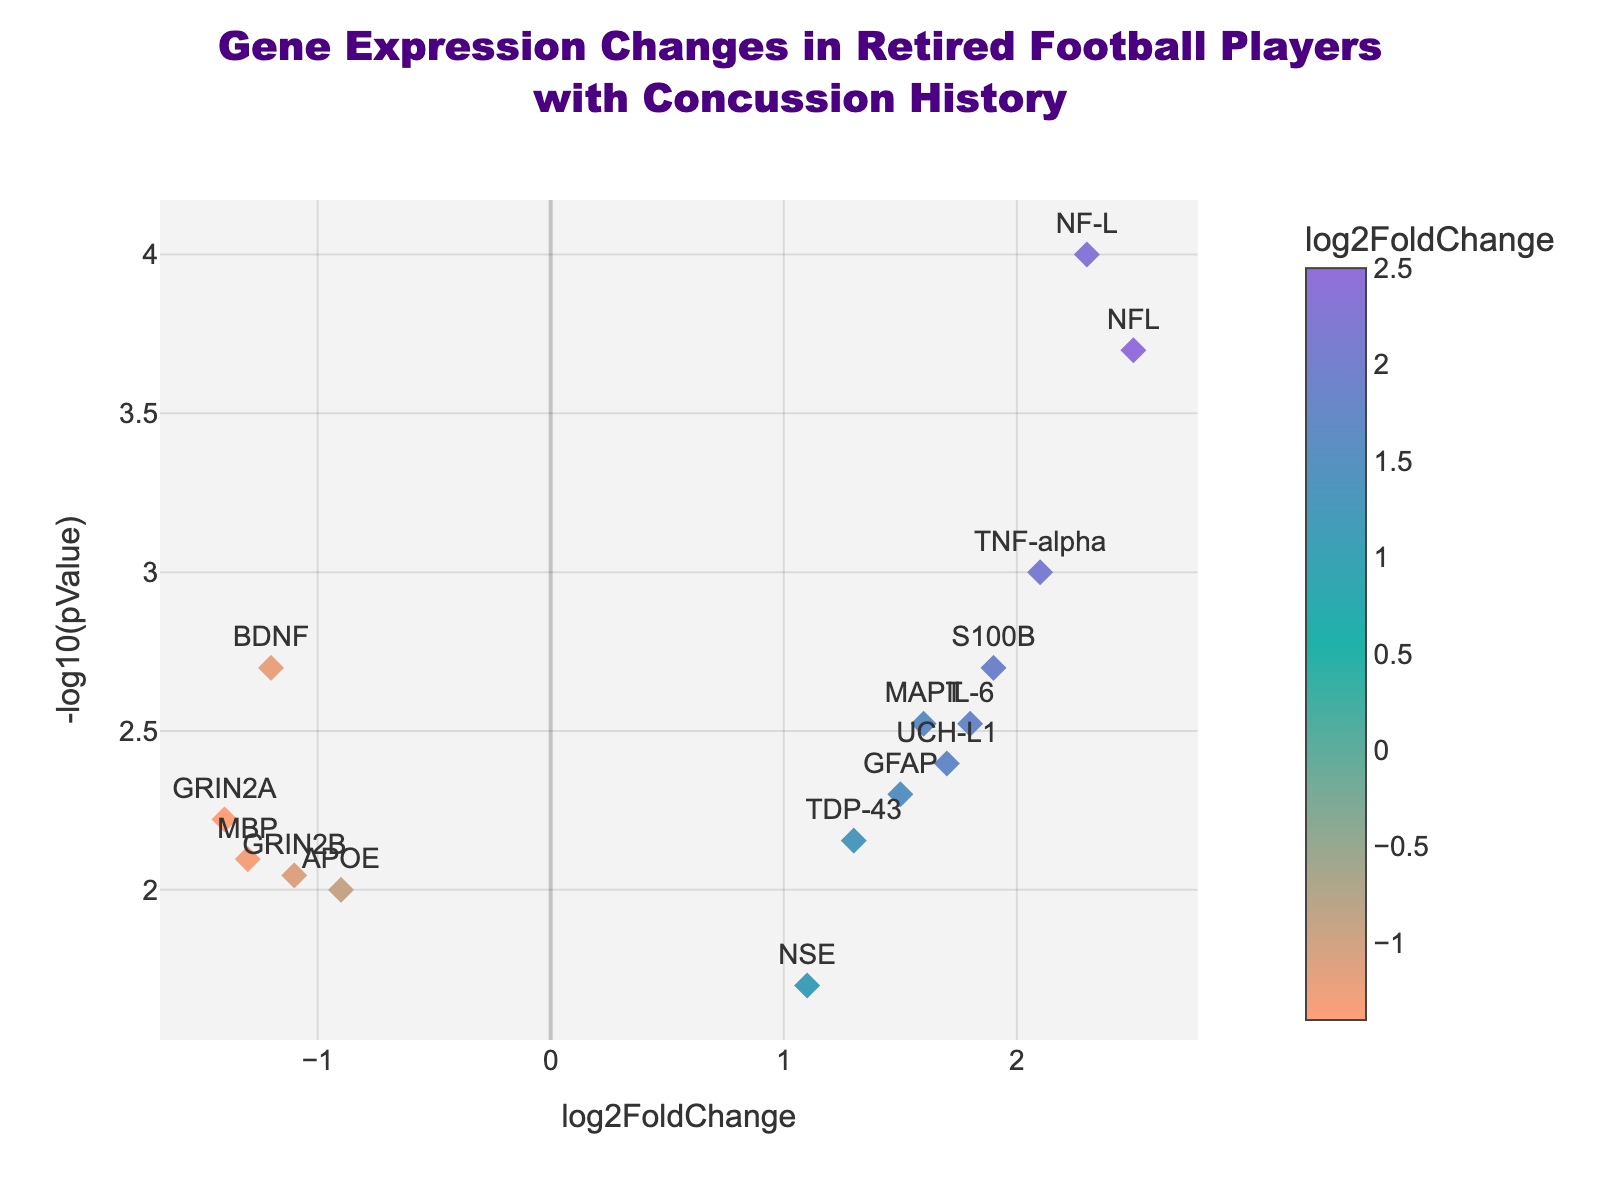What's the title of the figure? The title is displayed at the top of the figure in large, bold text. It reads, "Gene Expression Changes in Retired Football Players with Concussion History".
Answer: Gene Expression Changes in Retired Football Players with Concussion History How many genes have positive log2FoldChange values? Positive log2FoldChange values are shown on the right side of the x-axis. By counting the data points with positive log2FoldChange values, we see there are nine such genes.
Answer: 9 Which gene has the highest -log10(pValue)? The -log10(pValue) is shown on the y-axis. The gene with the highest value would be the one plotted highest on the y-axis. NF-L is the highest, indicating it has the lowest p-value.
Answer: NF-L What's the log2FoldChange and p-value of TNF-alpha? Hovering over the TNF-alpha data point displays a tooltip with this information. According to the tooltip, log2FoldChange is 2.1, and p-value is 0.001.
Answer: log2FoldChange: 2.1, p-value: 0.001 Which is more downregulated, BDNF or APOE? Downregulated genes have negative log2FoldChange values. To determine which is more downregulated, compare the log2FoldChange values. BDNF has -1.2, and APOE has -0.9. Since -1.2 is more negative, BDNF is more downregulated.
Answer: BDNF Which gene is both highly expressed (log2FoldChange > 2) and statistically significant (p-value < 0.001)? High expression and statistical significance criteria are given. NF-L fits both, as its log2FoldChange is 2.5 and its p-value is 0.0002.
Answer: NF-L For the genes with names starting with 'G', which has the smallest p-value? Look at genes: GFAP, GRIN2A, GRIN2B. By comparing p-values, GRIN2A has the smallest p-value of 0.006.
Answer: GRIN2A What's the average log2FoldChange for UCH-L1 and MAPT? Find the log2FoldChange for UCH-L1 (1.7) and MAPT (1.6). Sum these values (1.7 + 1.6 = 3.3) and divide by 2 to get the average: 3.3 / 2 = 1.65.
Answer: 1.65 How many genes have a p-value smaller than 0.005? Count the number of data points where the p-value is less than 0.005. There are six such genes: BDNF, TNF-alpha, IL-6, NF-L, S100B, MAPT.
Answer: 6 